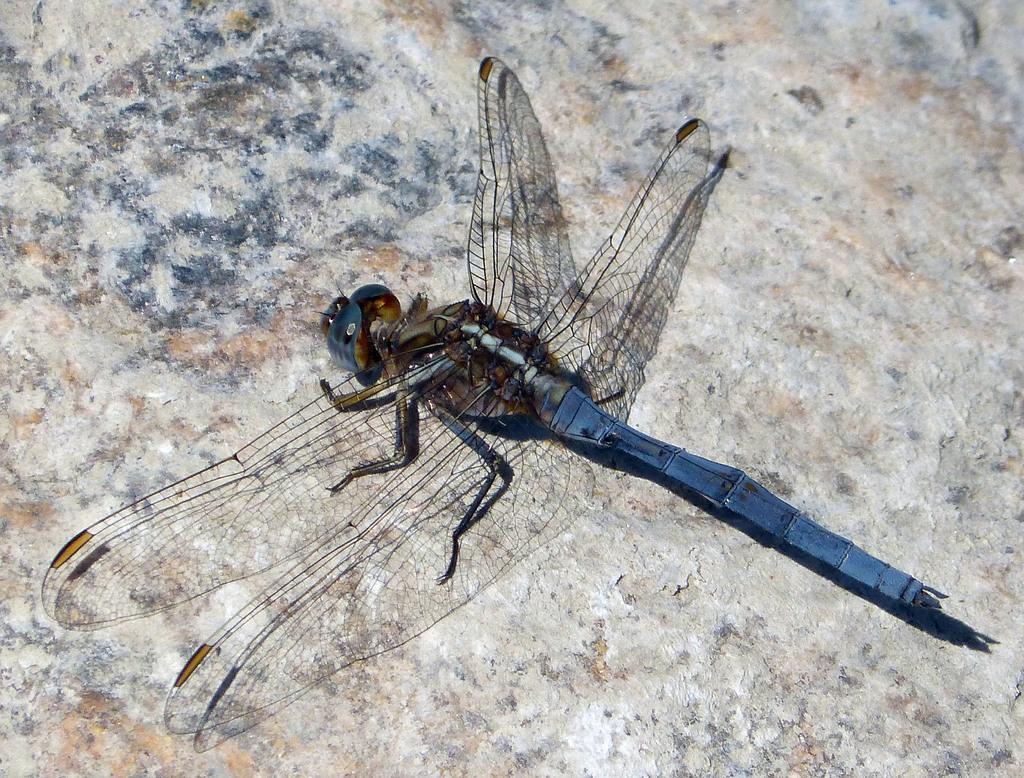Describe this image in one or two sentences. In this image I can see an insect. The background is looking like a stone. 